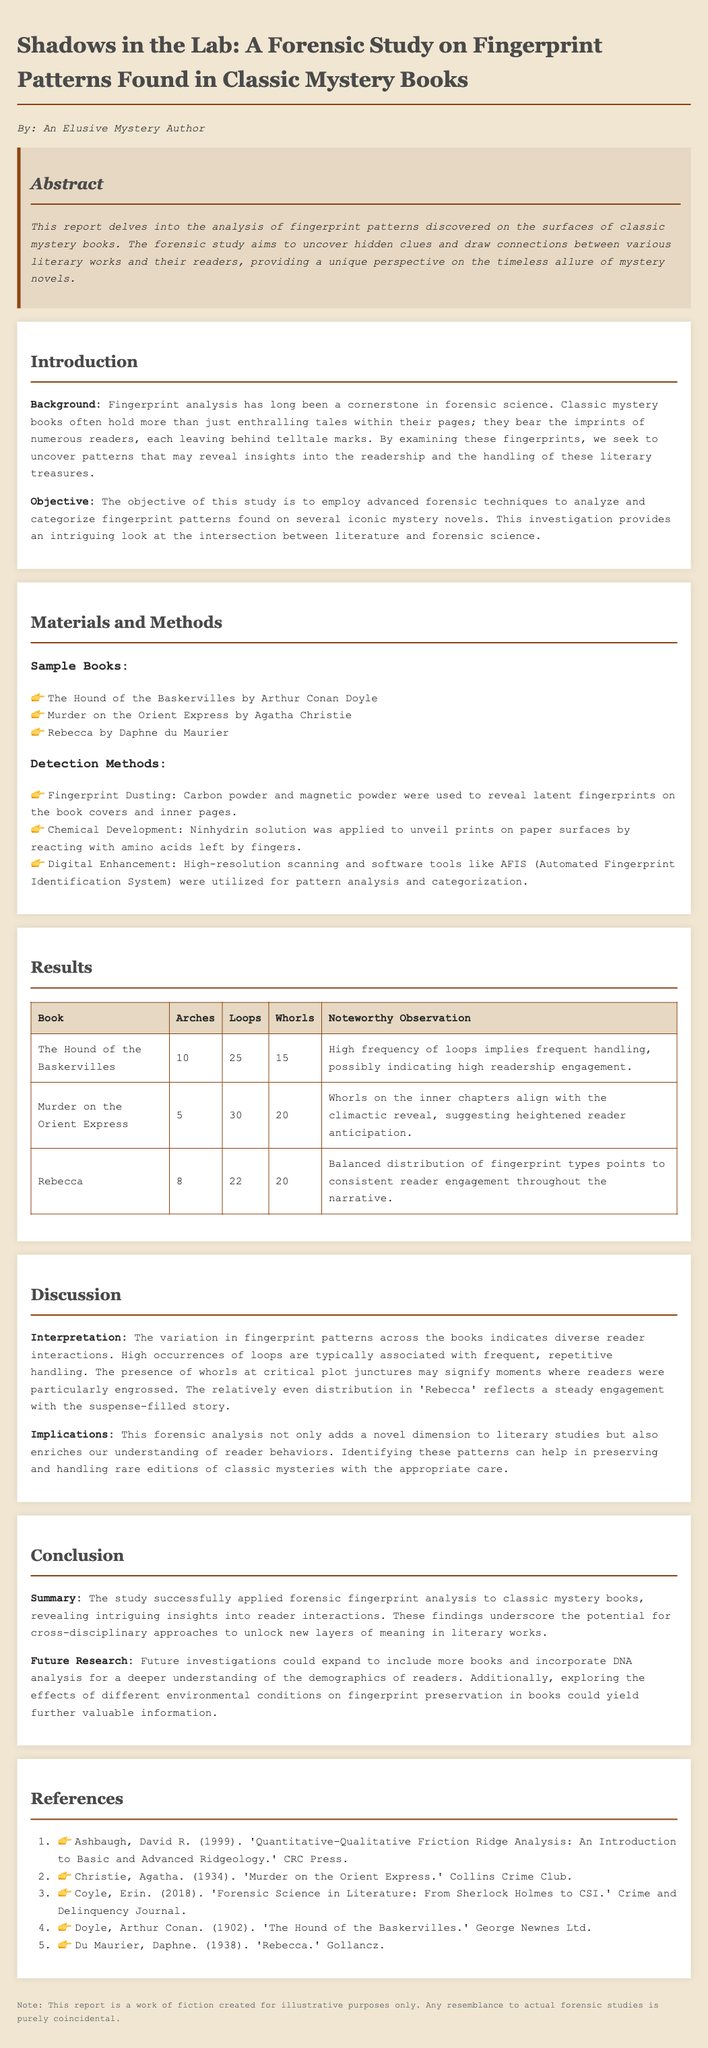What are the sample books analyzed in this study? The sample books listed in the materials section include "The Hound of the Baskervilles," "Murder on the Orient Express," and "Rebecca."
Answer: The Hound of the Baskervilles, Murder on the Orient Express, Rebecca What was applied to unveil prints on paper surfaces? The document states that a Ninhydrin solution was applied to paper surfaces to reveal prints by reacting with amino acids.
Answer: Ninhydrin solution How many arches were found in "Murder on the Orient Express"? The results table indicates that there were 5 arches found in "Murder on the Orient Express."
Answer: 5 What observation is noted for "The Hound of the Baskervilles"? The noteworthy observation for this book highlights the high frequency of loops suggesting frequent handling by readers.
Answer: High frequency of loops implies frequent handling What is the focus of future research mentioned in the report? Future research could expand to include more books and possibly investigate the effects of different environmental conditions on fingerprint preservation.
Answer: More books and environmental conditions How does the study contribute to literary studies? The forensic analysis introduces a new dimension to literary studies by enriching the understanding of reader behaviors.
Answer: Enriches understanding of reader behaviors Which detection method involves carbon powder? The study mentions fingerprint dusting as a detection method that uses carbon powder to reveal latent fingerprints.
Answer: Fingerprint Dusting What percentage of loops was found in "Rebecca"? The results reveal that there were 22 loops found in "Rebecca," making it a specific quantity rather than a percentage.
Answer: 22 